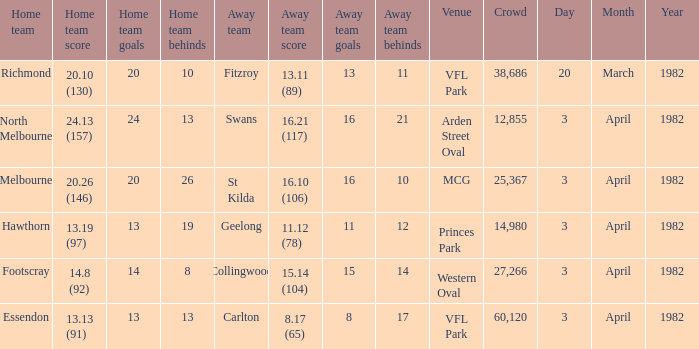Which domestic team faced the visiting team of collingwood? Footscray. Could you help me parse every detail presented in this table? {'header': ['Home team', 'Home team score', 'Home team goals', 'Home team behinds', 'Away team', 'Away team score', 'Away team goals', 'Away team behinds', 'Venue', 'Crowd', 'Day', 'Month', 'Year'], 'rows': [['Richmond', '20.10 (130)', '20', '10', 'Fitzroy', '13.11 (89)', '13', '11', 'VFL Park', '38,686', '20', 'March', '1982'], ['North Melbourne', '24.13 (157)', '24', '13', 'Swans', '16.21 (117)', '16', '21', 'Arden Street Oval', '12,855', '3', 'April', '1982'], ['Melbourne', '20.26 (146)', '20', '26', 'St Kilda', '16.10 (106)', '16', '10', 'MCG', '25,367', '3', 'April', '1982'], ['Hawthorn', '13.19 (97)', '13', '19', 'Geelong', '11.12 (78)', '11', '12', 'Princes Park', '14,980', '3', 'April', '1982'], ['Footscray', '14.8 (92)', '14', '8', 'Collingwood', '15.14 (104)', '15', '14', 'Western Oval', '27,266', '3', 'April', '1982'], ['Essendon', '13.13 (91)', '13', '13', 'Carlton', '8.17 (65)', '8', '17', 'VFL Park', '60,120', '3', 'April', '1982']]} 